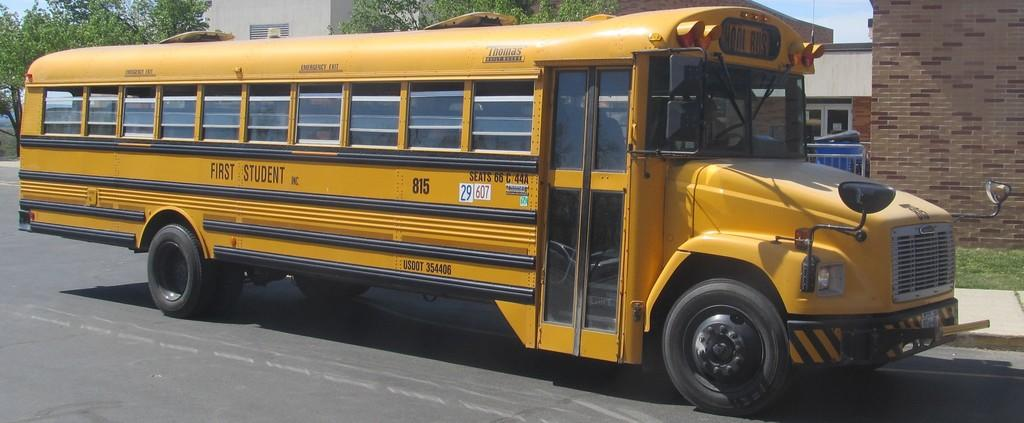What is on the road in the image? There is a vehicle on the road in the image. What type of vegetation can be seen on the path? Some grass is visible on the path. What can be seen in the background of the image? There is a barricade, a dustbin, a building, and trees in the background of the image. Can you describe the stranger's haircut in the image? There is no stranger present in the image, so it is not possible to describe their haircut. 